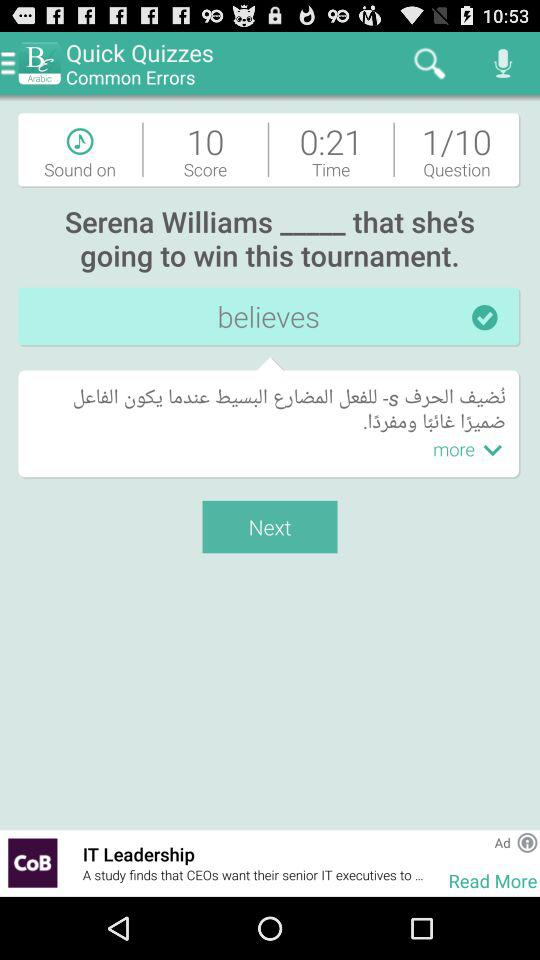Out of ten questions, how many are answered?
When the provided information is insufficient, respond with <no answer>. <no answer> 